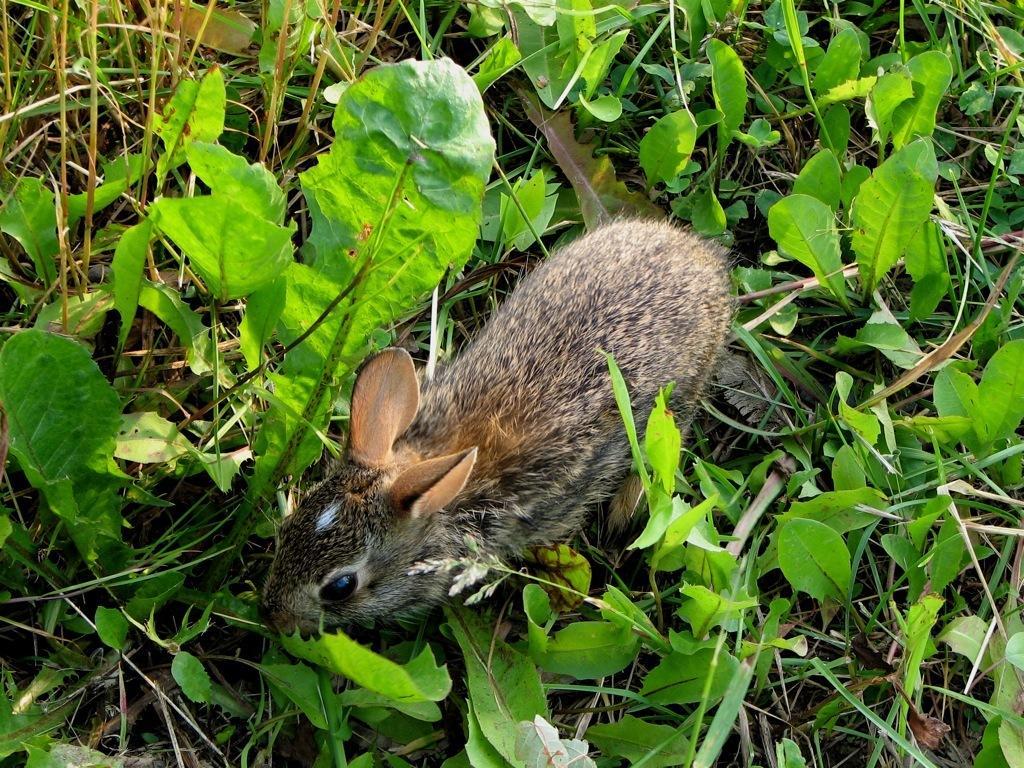Could you give a brief overview of what you see in this image? In this image we can see an animal on the ground and there are few plants. 